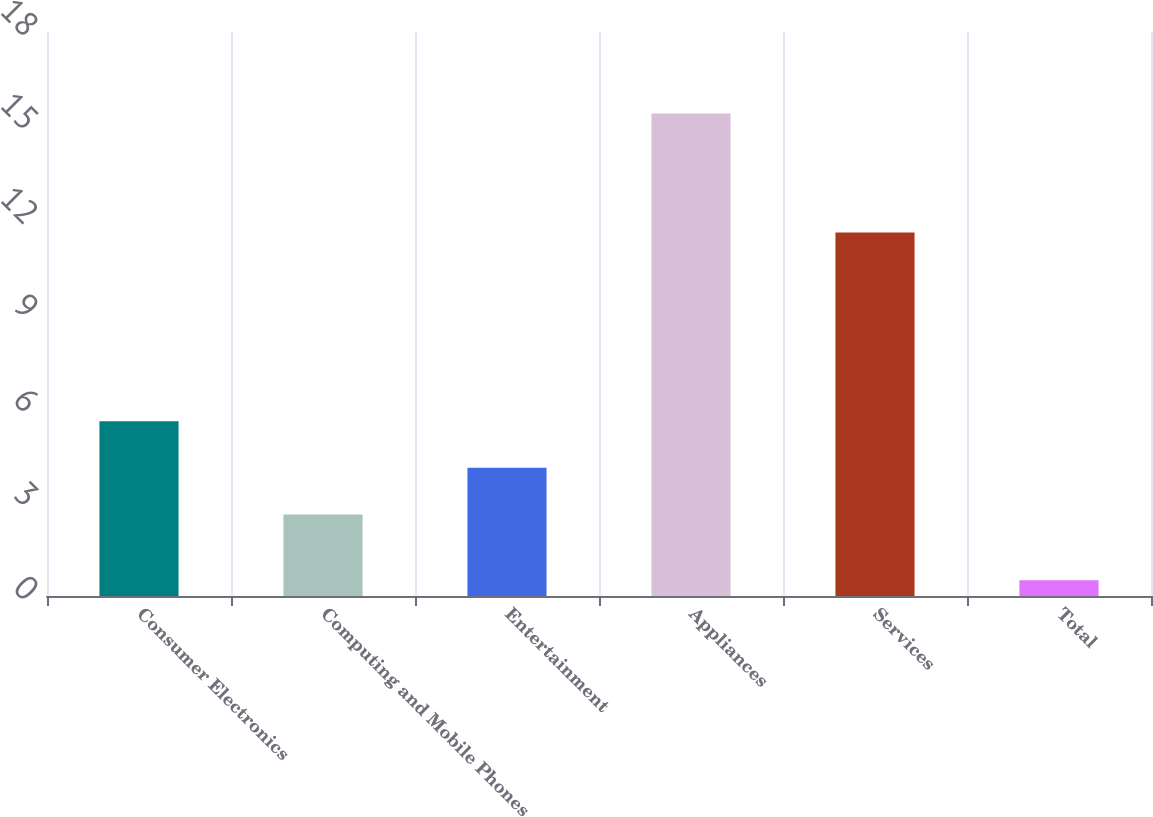Convert chart. <chart><loc_0><loc_0><loc_500><loc_500><bar_chart><fcel>Consumer Electronics<fcel>Computing and Mobile Phones<fcel>Entertainment<fcel>Appliances<fcel>Services<fcel>Total<nl><fcel>5.58<fcel>2.6<fcel>4.09<fcel>15.4<fcel>11.6<fcel>0.5<nl></chart> 